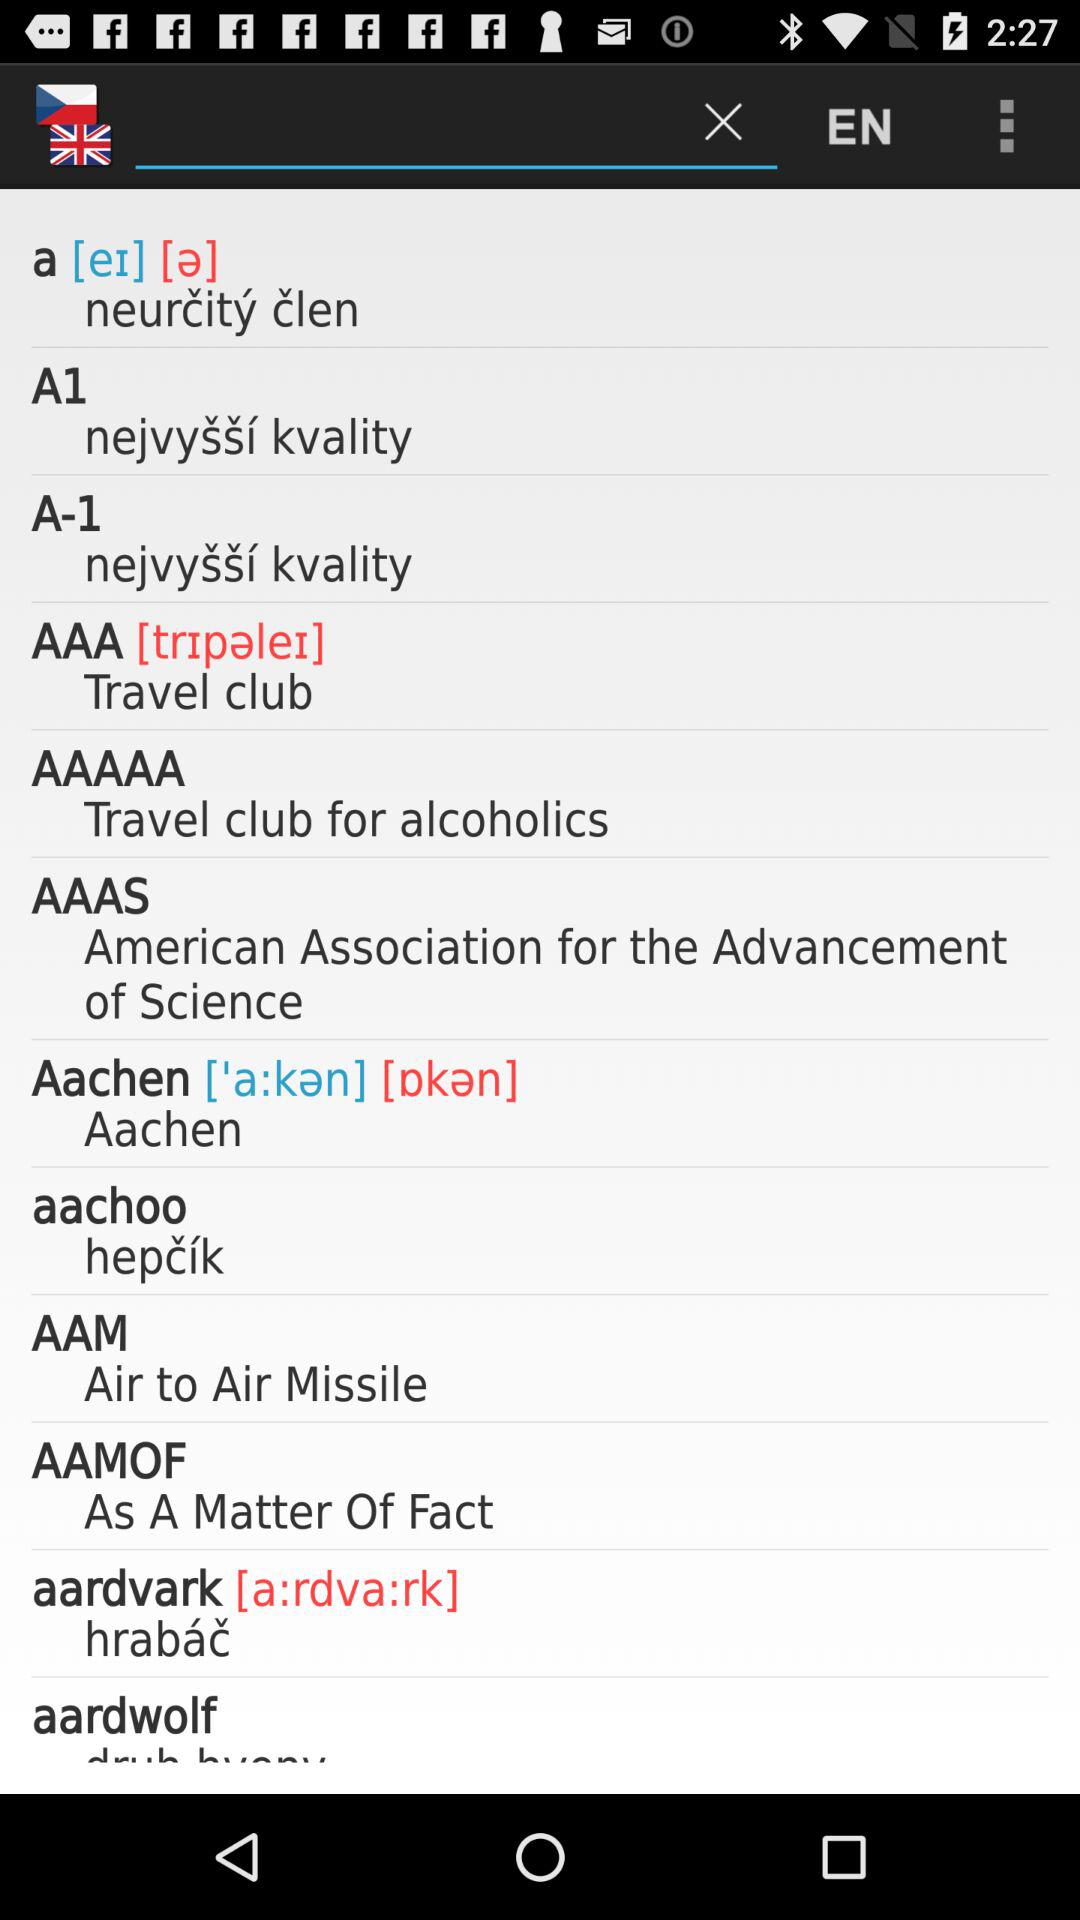What does AAMOF stand for in full? AAMOF stands for "As A Matter Of Fact". 